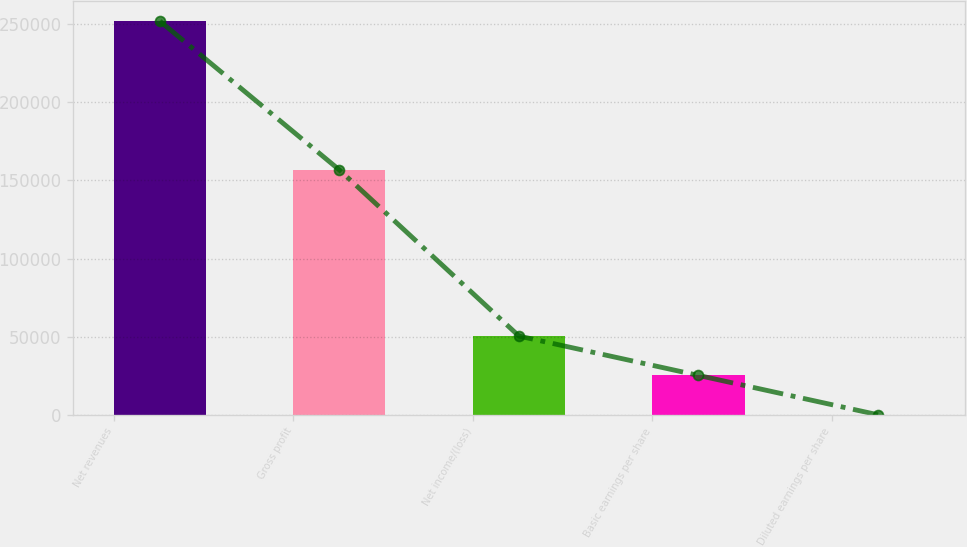Convert chart. <chart><loc_0><loc_0><loc_500><loc_500><bar_chart><fcel>Net revenues<fcel>Gross profit<fcel>Net income/(loss)<fcel>Basic earnings per share<fcel>Diluted earnings per share<nl><fcel>251959<fcel>156708<fcel>50392.3<fcel>25196.4<fcel>0.59<nl></chart> 